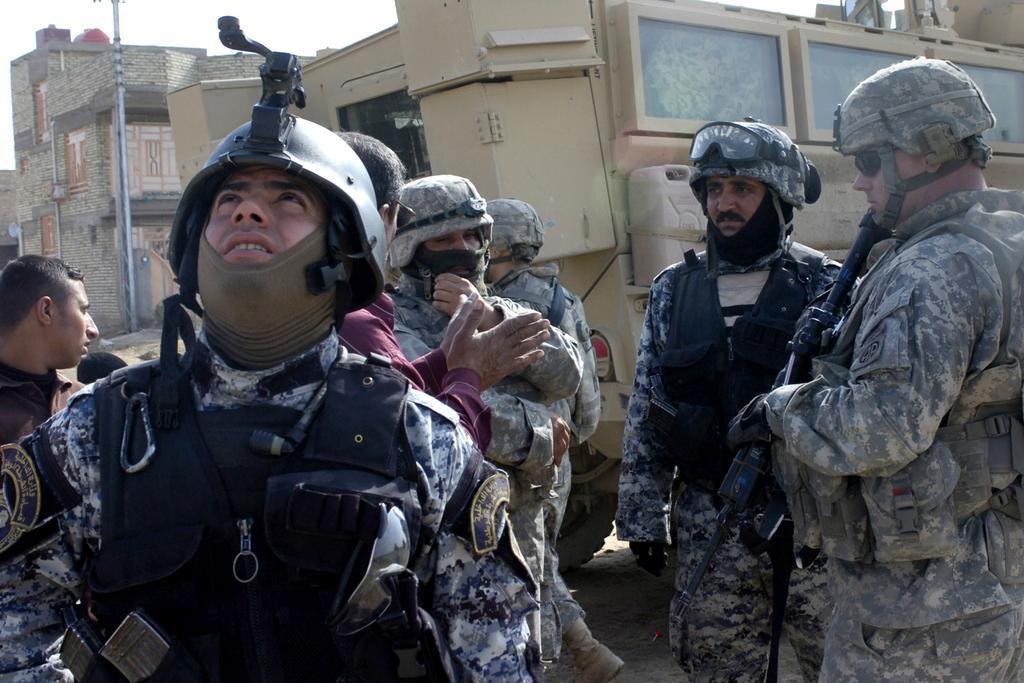Describe this image in one or two sentences. This picture is clicked outside. In the foreground we can see the group of persons wearing uniforms, helmets and standing. In the background we can see the sky, buildings, pole, vehicle, two persons and some other objects. 